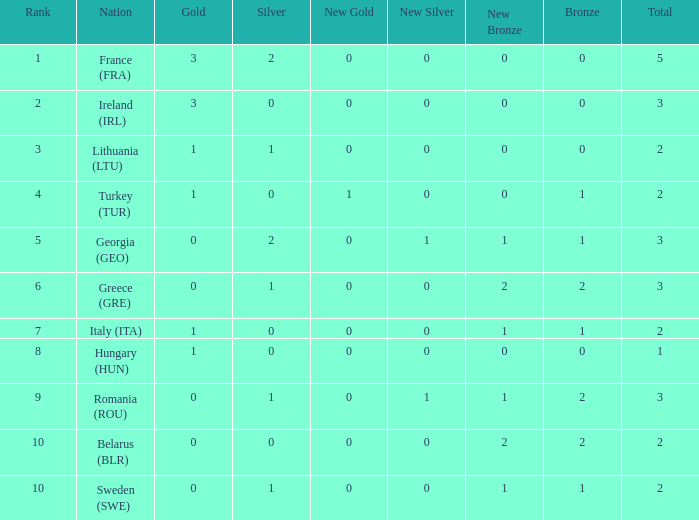I'm looking to parse the entire table for insights. Could you assist me with that? {'header': ['Rank', 'Nation', 'Gold', 'Silver', 'New Gold', 'New Silver', 'New Bronze', 'Bronze', 'Total'], 'rows': [['1', 'France (FRA)', '3', '2', '0', '0', '0', '0', '5'], ['2', 'Ireland (IRL)', '3', '0', '0', '0', '0', '0', '3'], ['3', 'Lithuania (LTU)', '1', '1', '0', '0', '0', '0', '2'], ['4', 'Turkey (TUR)', '1', '0', '1', '0', '0', '1', '2'], ['5', 'Georgia (GEO)', '0', '2', '0', '1', '1', '1', '3'], ['6', 'Greece (GRE)', '0', '1', '0', '0', '2', '2', '3'], ['7', 'Italy (ITA)', '1', '0', '0', '0', '1', '1', '2'], ['8', 'Hungary (HUN)', '1', '0', '0', '0', '0', '0', '1'], ['9', 'Romania (ROU)', '0', '1', '0', '1', '1', '2', '3'], ['10', 'Belarus (BLR)', '0', '0', '0', '0', '2', '2', '2'], ['10', 'Sweden (SWE)', '0', '1', '0', '0', '1', '1', '2']]} What's the total of Sweden (SWE) having less than 1 silver? None. 